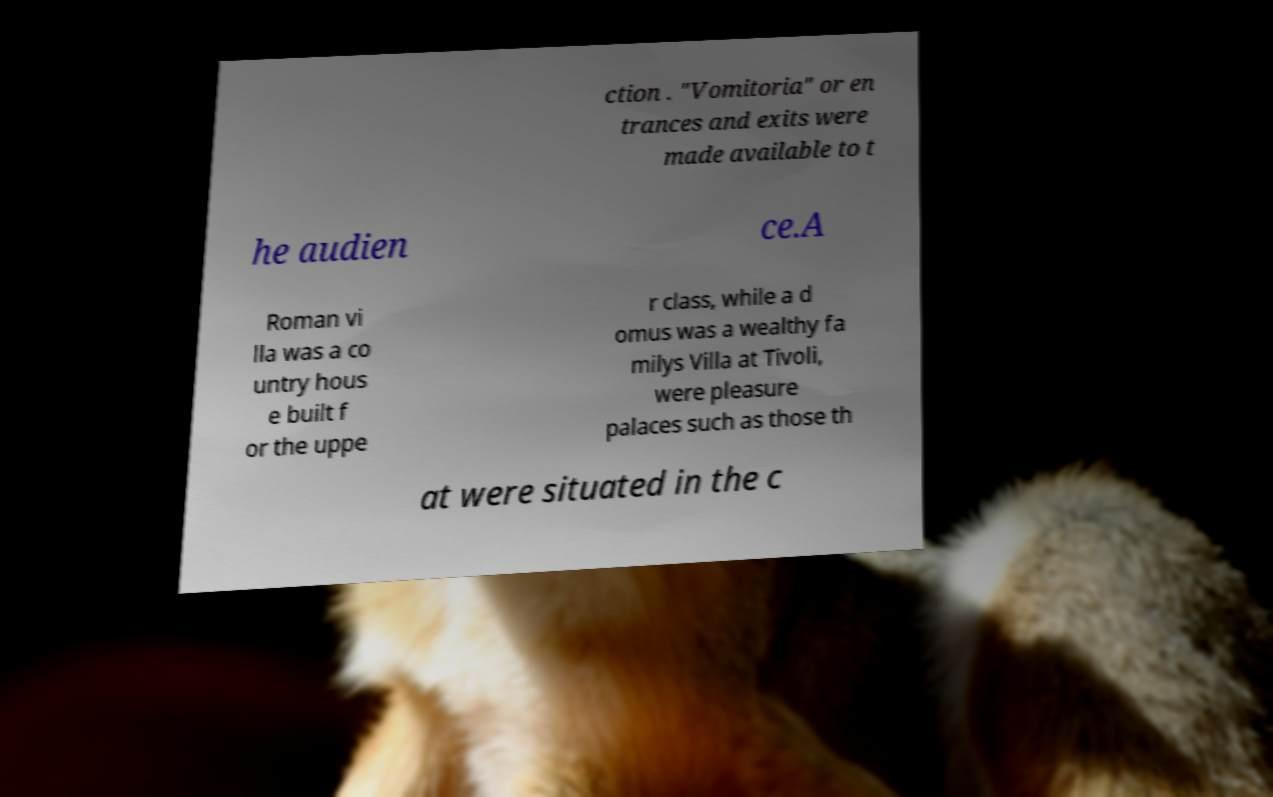Can you accurately transcribe the text from the provided image for me? ction . "Vomitoria" or en trances and exits were made available to t he audien ce.A Roman vi lla was a co untry hous e built f or the uppe r class, while a d omus was a wealthy fa milys Villa at Tivoli, were pleasure palaces such as those th at were situated in the c 